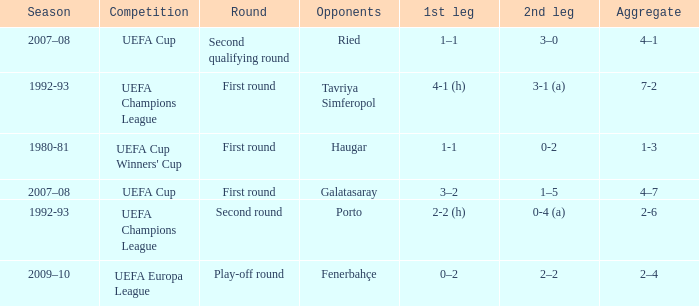 what's the competition where aggregate is 4–7 UEFA Cup. 